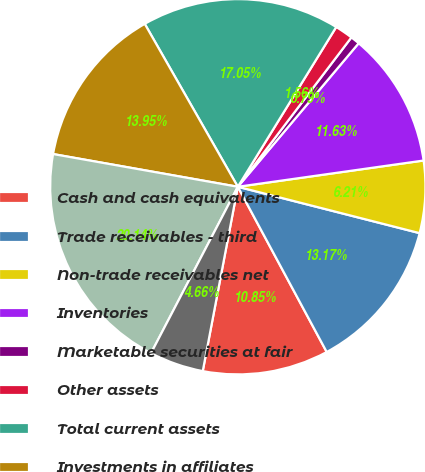Convert chart. <chart><loc_0><loc_0><loc_500><loc_500><pie_chart><fcel>Cash and cash equivalents<fcel>Trade receivables - third<fcel>Non-trade receivables net<fcel>Inventories<fcel>Marketable securities at fair<fcel>Other assets<fcel>Total current assets<fcel>Investments in affiliates<fcel>Property plant and equipment<fcel>Deferred income taxes<nl><fcel>10.85%<fcel>13.17%<fcel>6.21%<fcel>11.63%<fcel>0.79%<fcel>1.56%<fcel>17.05%<fcel>13.95%<fcel>20.14%<fcel>4.66%<nl></chart> 